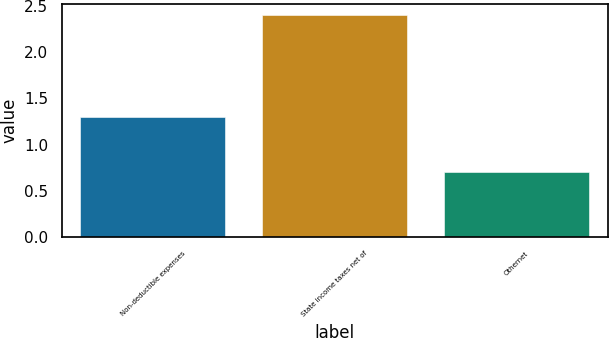Convert chart to OTSL. <chart><loc_0><loc_0><loc_500><loc_500><bar_chart><fcel>Non-deductible expenses<fcel>State income taxes net of<fcel>Othernet<nl><fcel>1.3<fcel>2.4<fcel>0.7<nl></chart> 